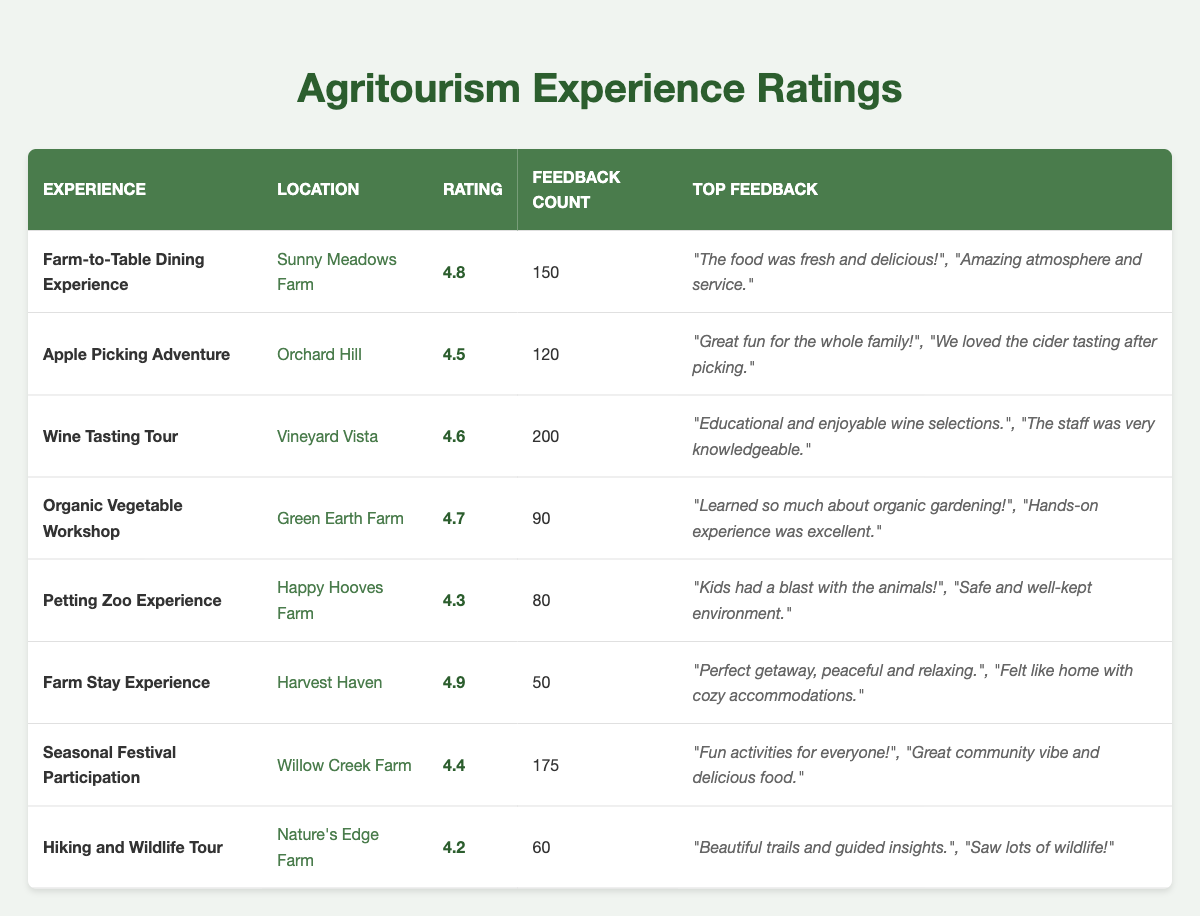What is the customer rating for the "Wine Tasting Tour"? The table shows that the "Wine Tasting Tour" has a customer rating of 4.6. This information can be found directly in the "Rating" column corresponding to the "Wine Tasting Tour" experience in the table.
Answer: 4.6 How many feedback comments are there for the "Farm Stay Experience"? The table indicates that the "Farm Stay Experience" received a total of 50 feedback comments, which can be seen in the "Feedback Count" column next to the "Farm Stay Experience" entry.
Answer: 50 Which experience has the highest customer rating? The "Farm Stay Experience" has the highest customer rating of 4.9, as shown in the "Rating" column where it is listed as the highest value compared to the other experiences.
Answer: 4.9 Is the average customer rating for the "Apple Picking Adventure" and "Petting Zoo Experience" above 4.4? The customer rating for the "Apple Picking Adventure" is 4.5 and for the "Petting Zoo Experience" it is 4.3. To calculate the average, (4.5 + 4.3) / 2 = 4.4, which is not above 4.4. Therefore, the average is equal to 4.4 and not greater.
Answer: No What experience has more than 100 feedback comments and its rating? The experiences with more than 100 feedback comments are the "Farm-to-Table Dining Experience" (150 comments, rating 4.8), "Wine Tasting Tour" (200 comments, rating 4.6), and "Seasonal Festival Participation" (175 comments, rating 4.4). Each can be read from their respective entries in the table.
Answer: "Farm-to-Table Dining Experience" with 150 comments, rating 4.8; "Wine Tasting Tour" with 200 comments, rating 4.6; "Seasonal Festival Participation" with 175 comments, rating 4.4 What percentage of feedback comments did the "Farm Stay Experience" receive compared to the total feedback of all experiences? The total feedback comments across all experiences are 150 + 120 + 200 + 90 + 80 + 50 + 175 + 60 = 1025. The "Farm Stay Experience" received 50 comments. To find the percentage, (50 / 1025) * 100 ≈ 4.88%. Therefore, the "Farm Stay Experience" accounts for approximately 4.88% of the total feedback comments.
Answer: Approximately 4.88% 